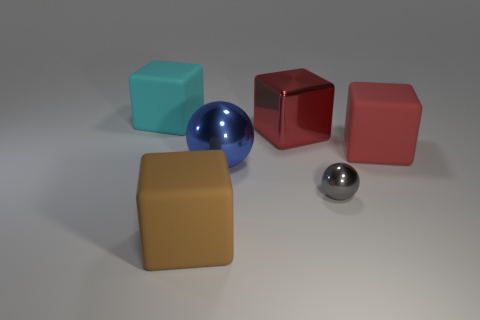Is there a big cyan thing made of the same material as the small gray thing?
Offer a very short reply. No. There is a big rubber thing in front of the blue ball; is there a large object that is left of it?
Provide a succinct answer. Yes. There is a red cube right of the red metal block; is it the same size as the cyan object?
Make the answer very short. Yes. What size is the gray ball?
Ensure brevity in your answer.  Small. Are there any large matte objects of the same color as the large shiny cube?
Your response must be concise. Yes. How many small objects are either brown balls or brown rubber blocks?
Keep it short and to the point. 0. There is a thing that is both behind the large brown cube and in front of the large blue thing; how big is it?
Offer a very short reply. Small. How many objects are behind the large sphere?
Provide a succinct answer. 3. The large object that is on the right side of the blue metal object and in front of the metallic cube has what shape?
Make the answer very short. Cube. How many cylinders are either blue metal objects or brown objects?
Provide a succinct answer. 0. 